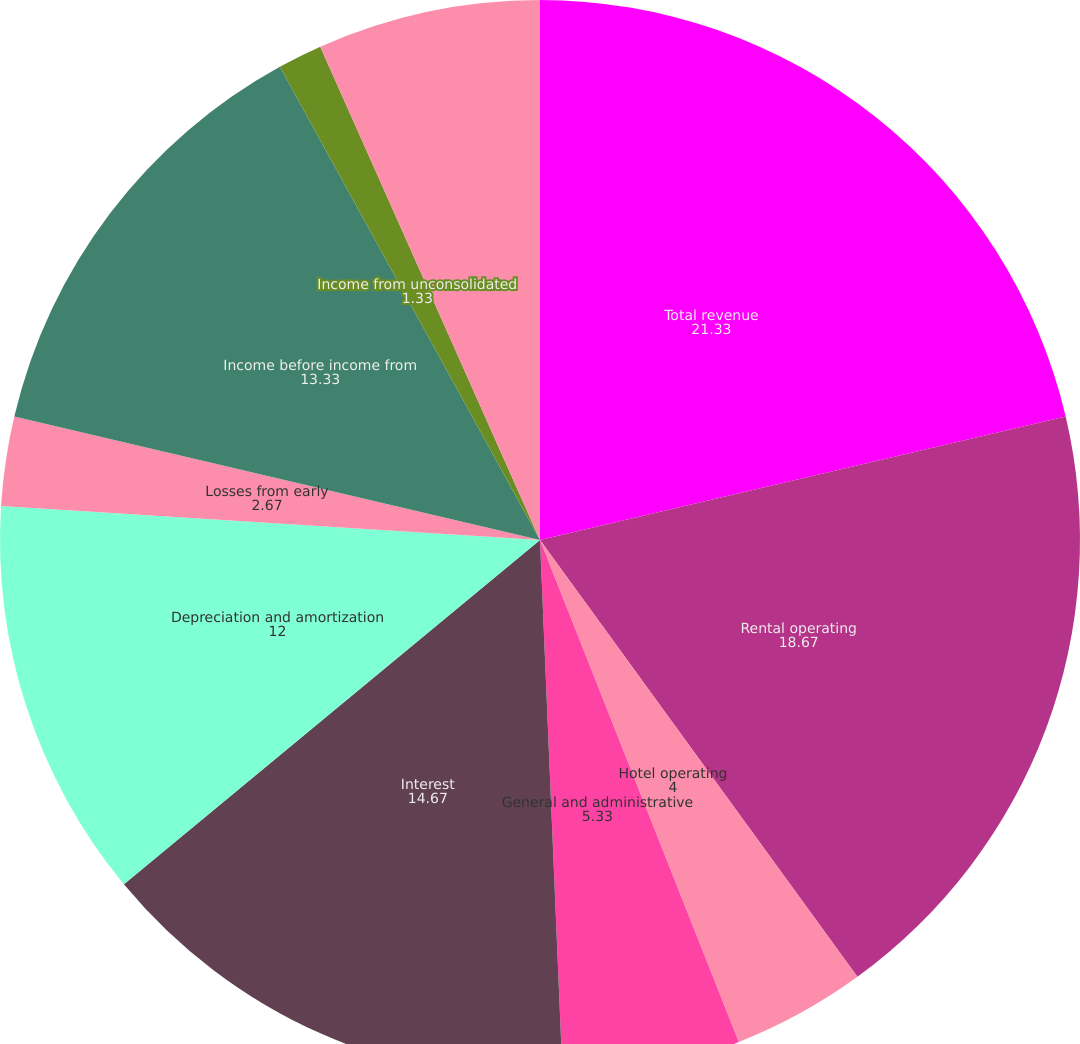<chart> <loc_0><loc_0><loc_500><loc_500><pie_chart><fcel>Total revenue<fcel>Rental operating<fcel>Hotel operating<fcel>General and administrative<fcel>Interest<fcel>Depreciation and amortization<fcel>Losses from early<fcel>Income before income from<fcel>Income from unconsolidated<fcel>Minority interests<nl><fcel>21.33%<fcel>18.67%<fcel>4.0%<fcel>5.33%<fcel>14.67%<fcel>12.0%<fcel>2.67%<fcel>13.33%<fcel>1.33%<fcel>6.67%<nl></chart> 